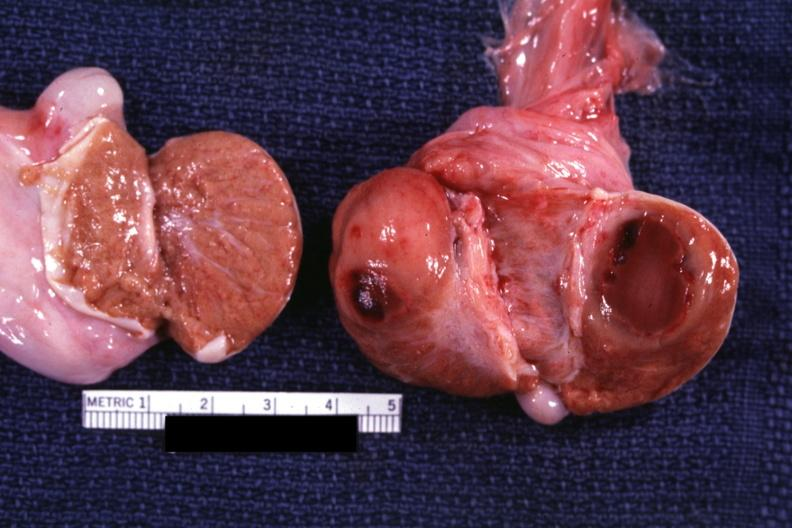s leukemic infiltrate with necrosis present?
Answer the question using a single word or phrase. Yes 